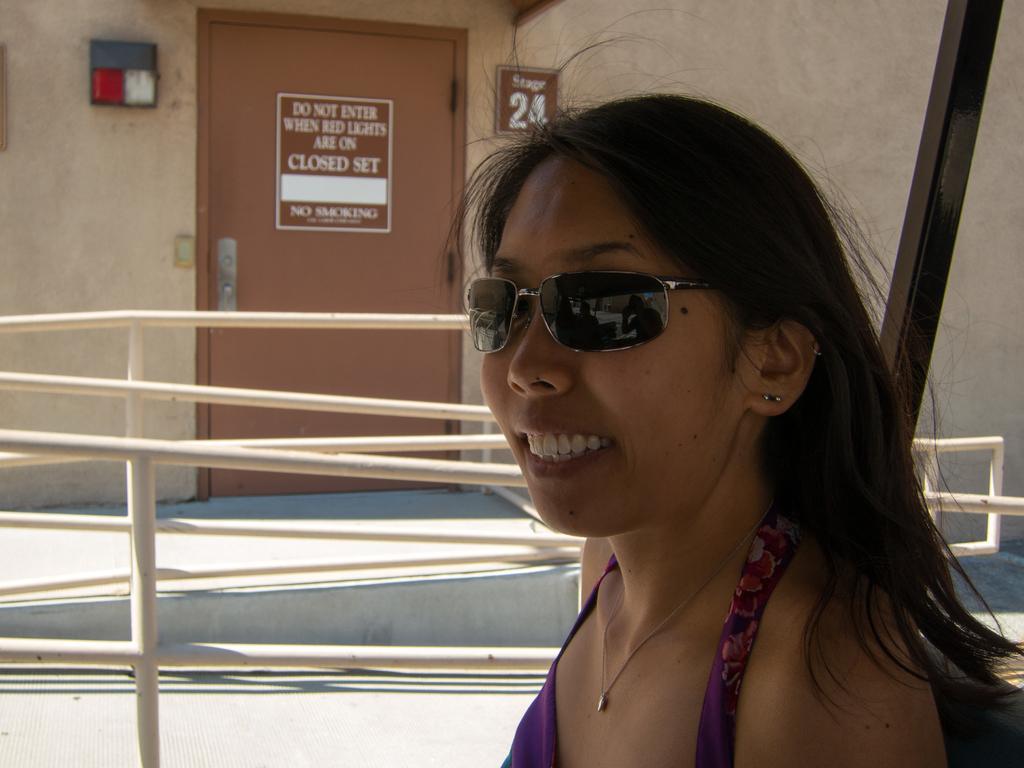Could you give a brief overview of what you see in this image? In this picture I can see there is a woman standing on to right and she is wearing a violet dress and goggles. She is smiling and there is a railing in the backdrop, there is a door and there is something written on it. There is a wall beside the door. 